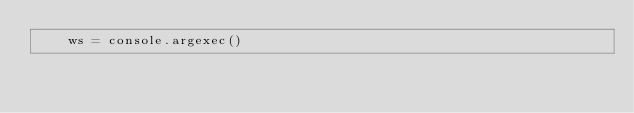Convert code to text. <code><loc_0><loc_0><loc_500><loc_500><_Python_>    ws = console.argexec()     </code> 